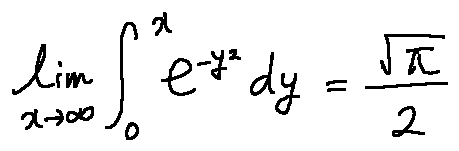<formula> <loc_0><loc_0><loc_500><loc_500>\lim \lim i t s _ { x \rightarrow \infty } \int \lim i t s _ { 0 } ^ { x } e ^ { - y ^ { 2 } } d y = \frac { \sqrt { \pi } } { 2 }</formula> 